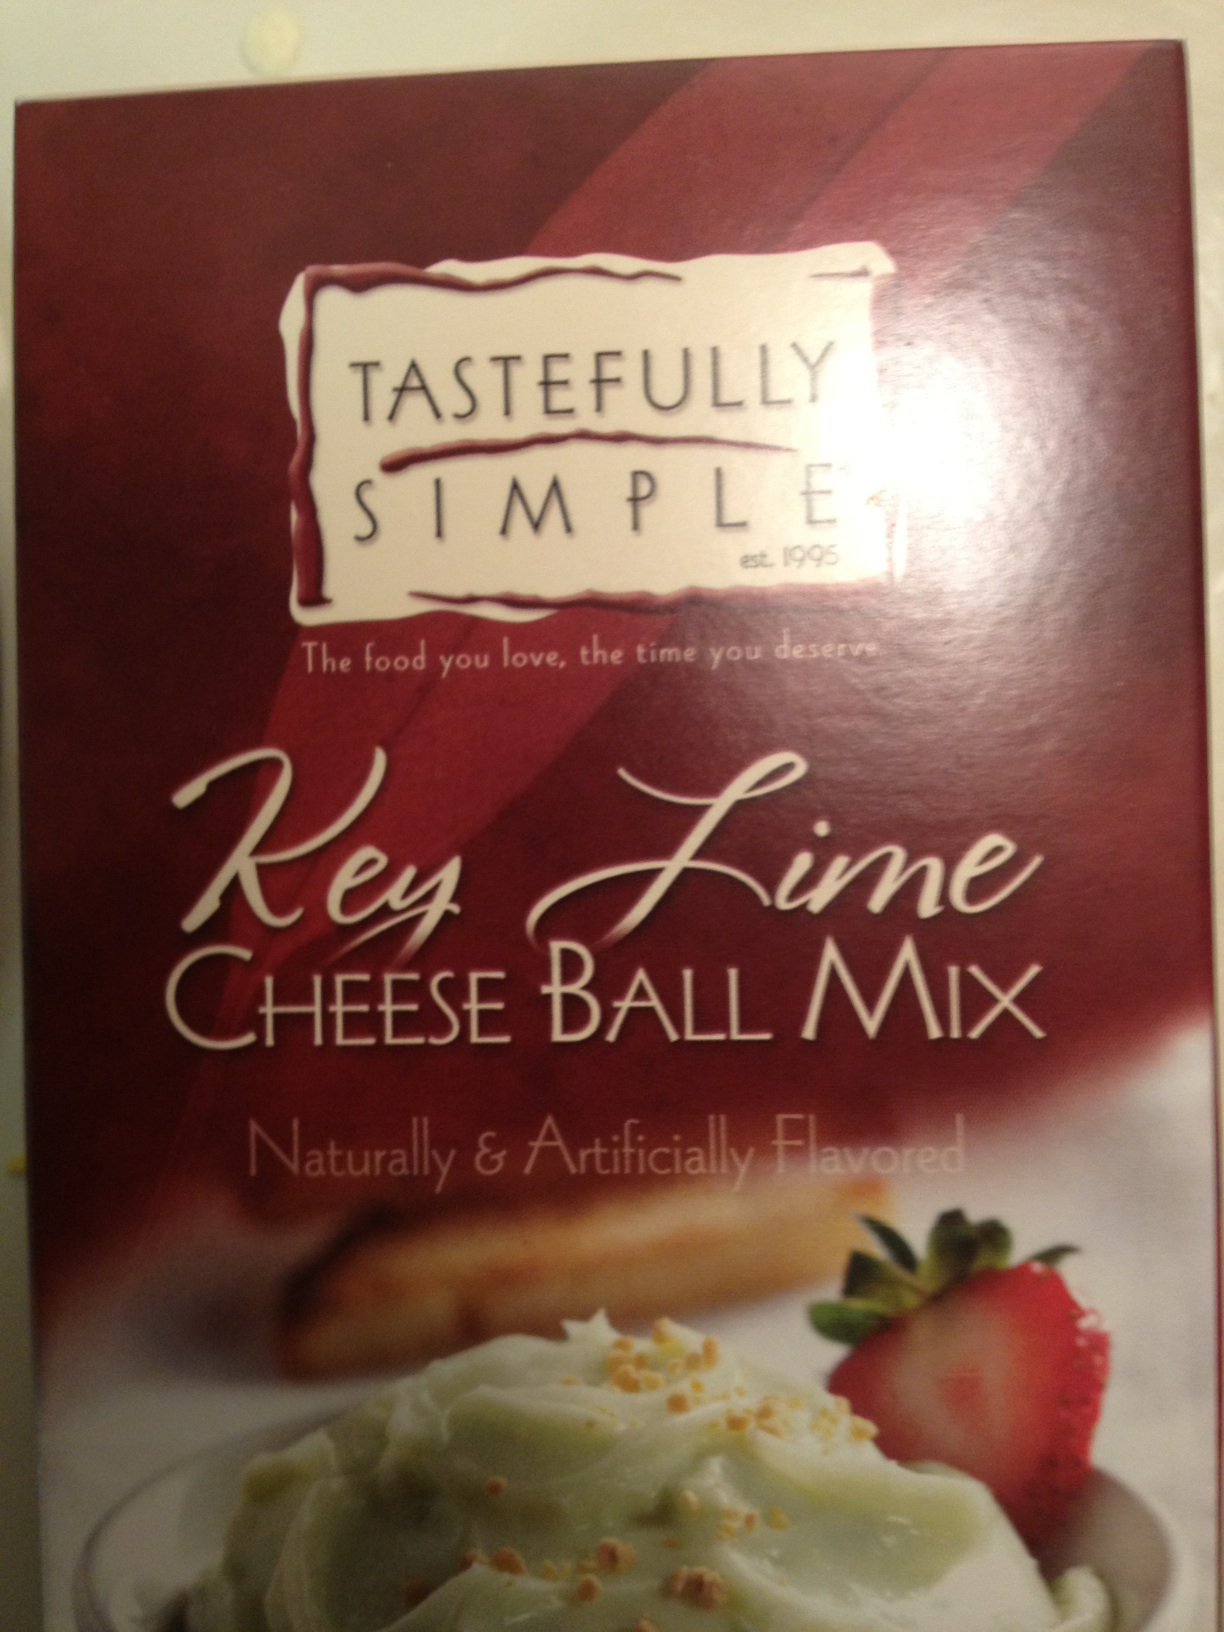Can you tell me more about how this product is used? Certainly! The 'Key Lime Cheese Ball Mix' includes ingredients that you blend with cream cheese to create a cheese ball. It's often garnished with nuts or zest and served chilled as a sweet and tangy snack or dessert, perfect for parties or gatherings. What key ingredients might this mix contain? The mix likely contains key lime flavoring, along with sugar and possibly other flavor enhancers or stabilizers that help achieve the desired taste and texture. 